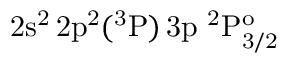Convert formula to latex. <formula><loc_0><loc_0><loc_500><loc_500>2 s ^ { 2 } \, 2 p ^ { 2 } ( ^ { 3 } P ) \, 3 p ^ { 2 } P _ { 3 / 2 } ^ { o }</formula> 